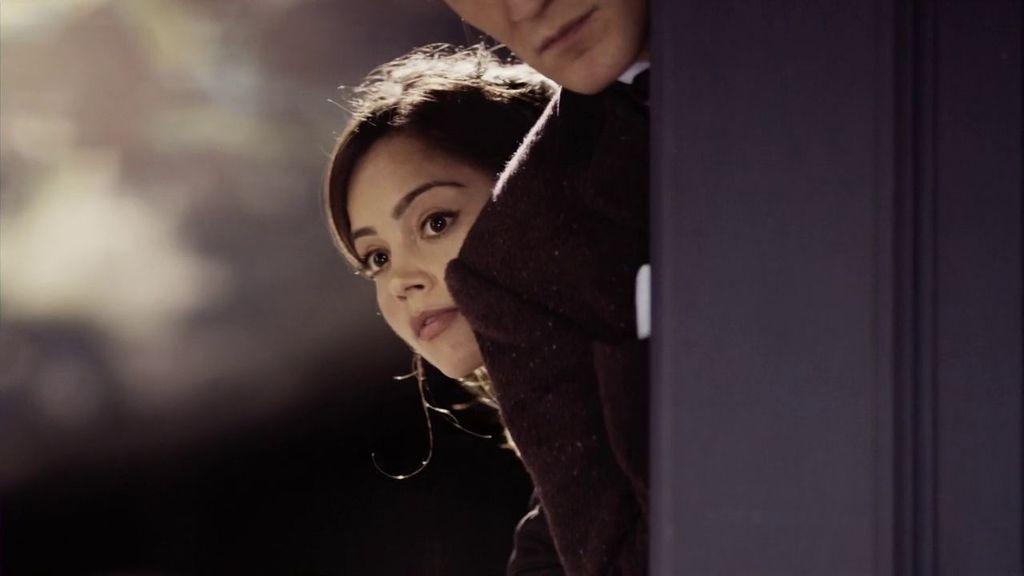How would you summarize this image in a sentence or two? In this image on the right side, I can see the door. I can see two people. I can also see the background is blurred. 